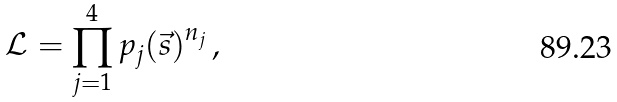Convert formula to latex. <formula><loc_0><loc_0><loc_500><loc_500>\mathcal { L } = \prod _ { j = 1 } ^ { 4 } { p _ { j } ( \vec { s } ) } ^ { n _ { j } } \, ,</formula> 